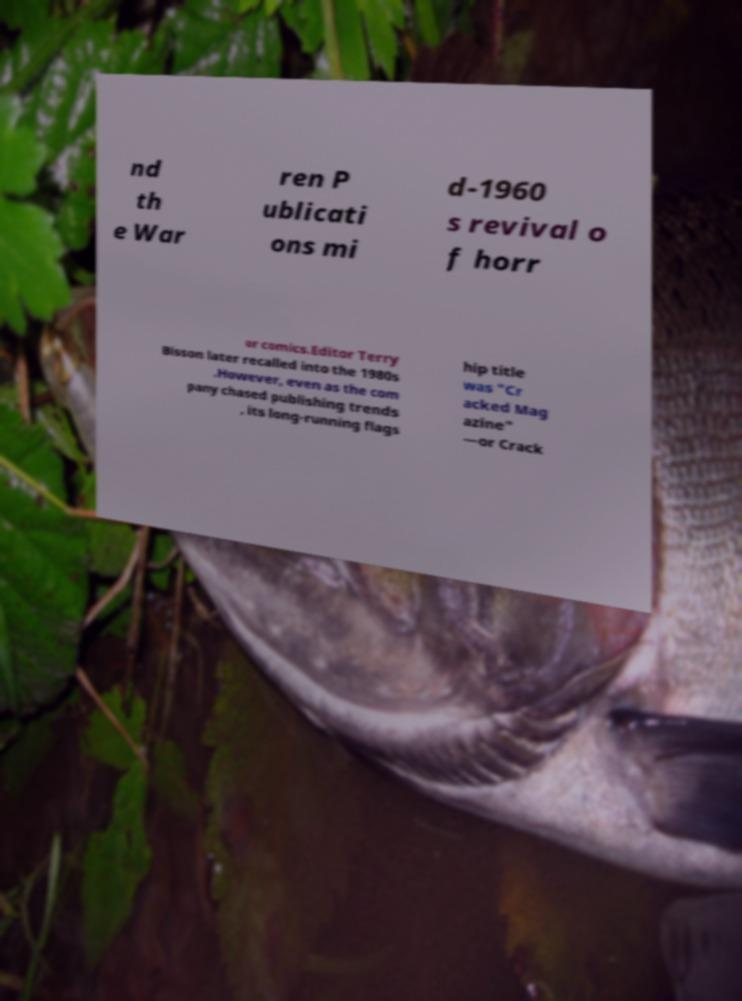For documentation purposes, I need the text within this image transcribed. Could you provide that? nd th e War ren P ublicati ons mi d-1960 s revival o f horr or comics.Editor Terry Bisson later recalled into the 1980s .However, even as the com pany chased publishing trends , its long-running flags hip title was "Cr acked Mag azine" —or Crack 